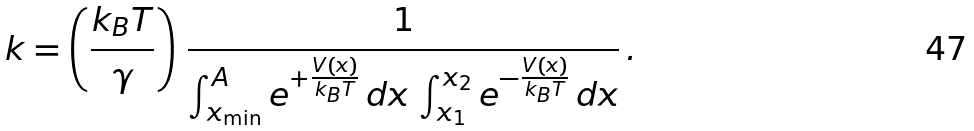<formula> <loc_0><loc_0><loc_500><loc_500>k = \left ( \frac { k _ { B } T } { \gamma } \right ) \, \frac { 1 } { \int ^ { A } _ { x _ { \min } } e ^ { + \frac { V ( x ) } { k _ { B } T } } \, d x \, \int _ { x _ { 1 } } ^ { x _ { 2 } } e ^ { - \frac { V ( x ) } { k _ { B } T } } \, d x } \, .</formula> 